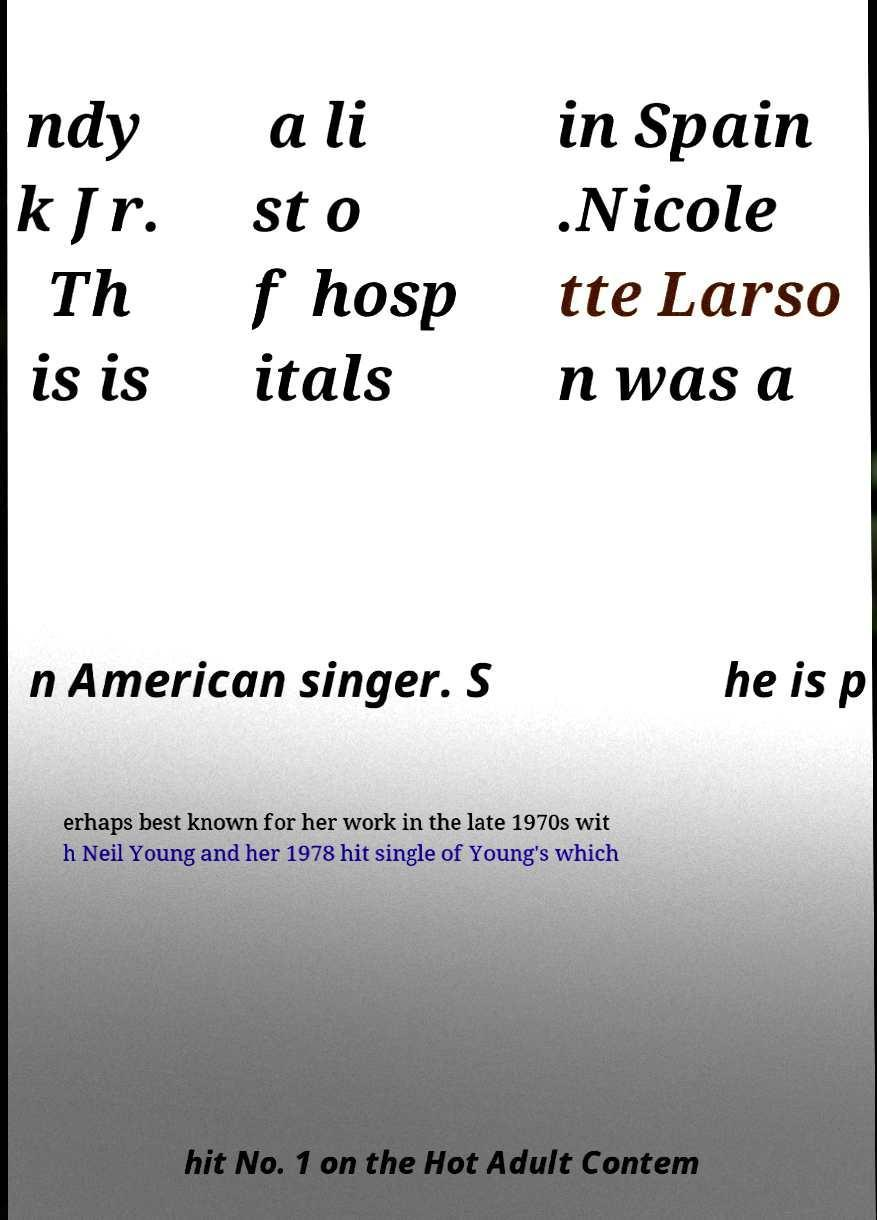For documentation purposes, I need the text within this image transcribed. Could you provide that? ndy k Jr. Th is is a li st o f hosp itals in Spain .Nicole tte Larso n was a n American singer. S he is p erhaps best known for her work in the late 1970s wit h Neil Young and her 1978 hit single of Young's which hit No. 1 on the Hot Adult Contem 